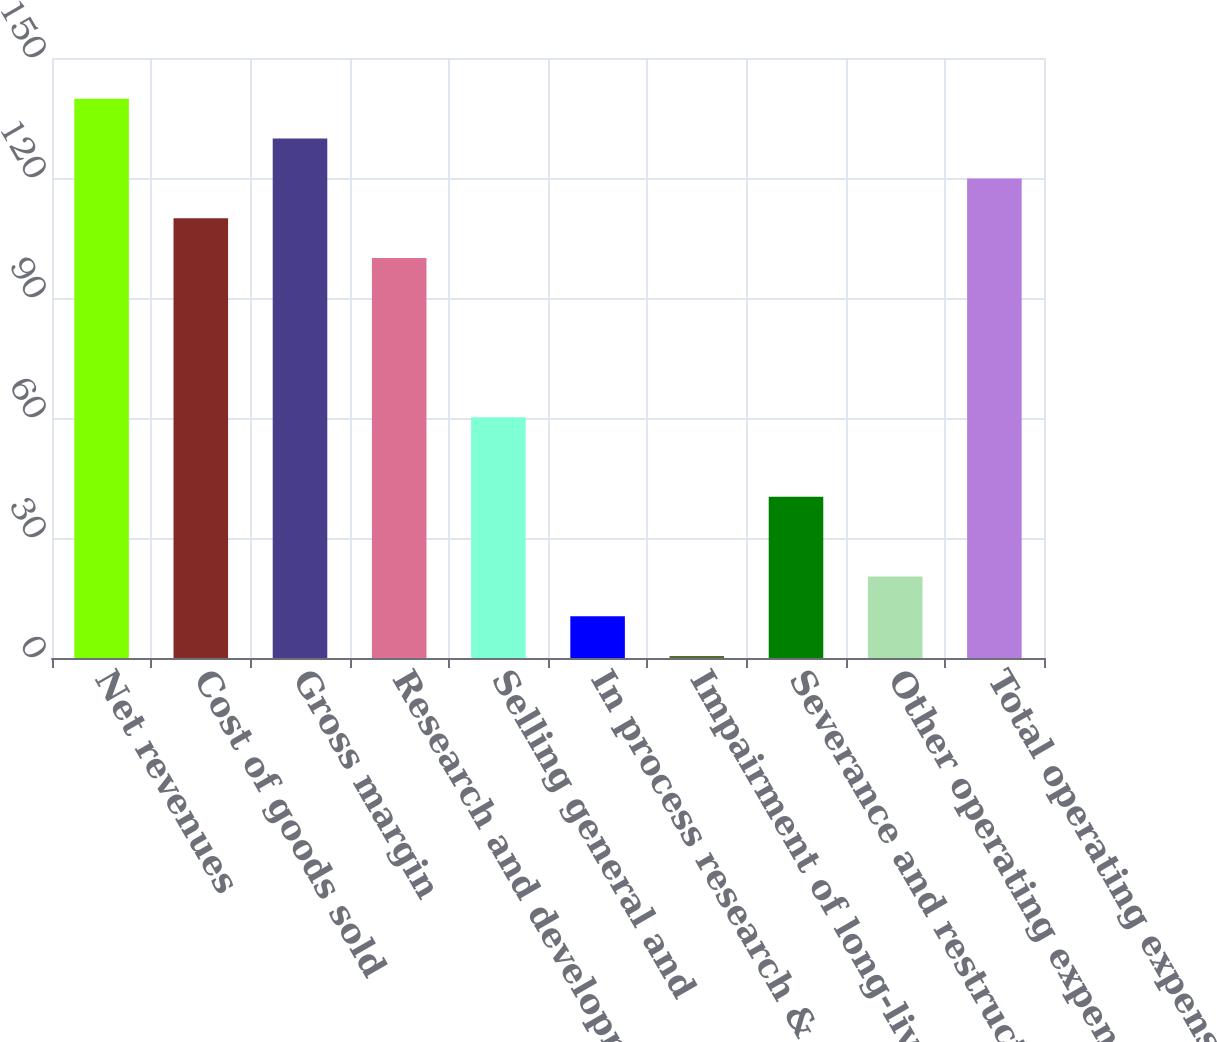<chart> <loc_0><loc_0><loc_500><loc_500><bar_chart><fcel>Net revenues<fcel>Cost of goods sold<fcel>Gross margin<fcel>Research and development<fcel>Selling general and<fcel>In process research &<fcel>Impairment of long-lived<fcel>Severance and restructing<fcel>Other operating expenses<fcel>Total operating expenses<nl><fcel>139.8<fcel>109.95<fcel>129.85<fcel>100<fcel>60.2<fcel>10.45<fcel>0.5<fcel>40.3<fcel>20.4<fcel>119.9<nl></chart> 